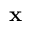<formula> <loc_0><loc_0><loc_500><loc_500>{ x }</formula> 